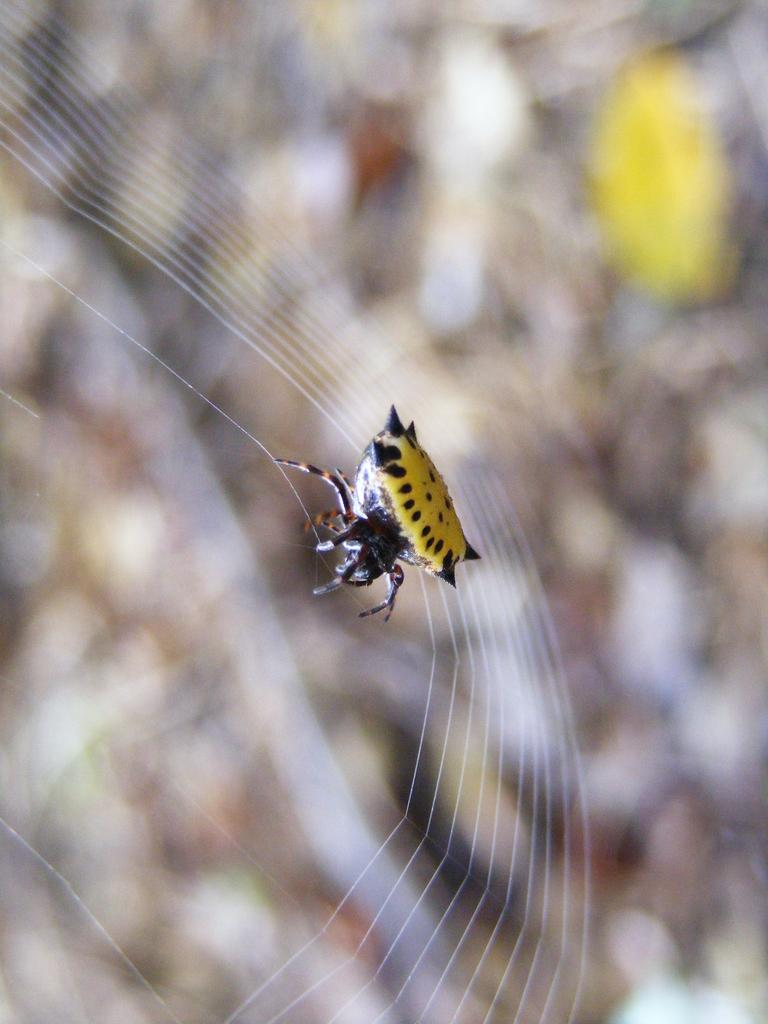What type of creature can be seen in the image? There is an insect in the image. What is the insect interacting with in the image? There is a web in the image. What type of mitten is the insect wearing in the image? There is no mitten present in the image, and insects do not wear clothing. 